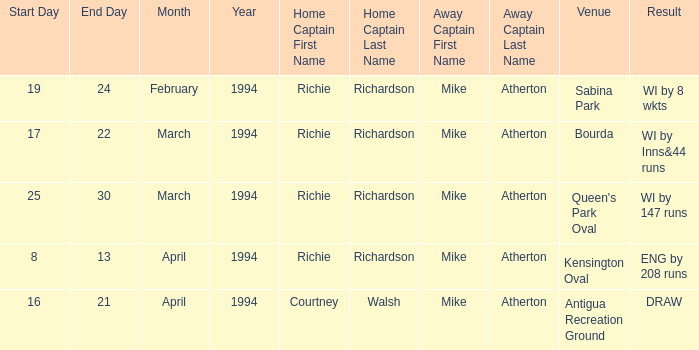Identify the home captain with a 1994 birthdate on march 25, 26, 27, 29, or 30. Richie Richardson. 